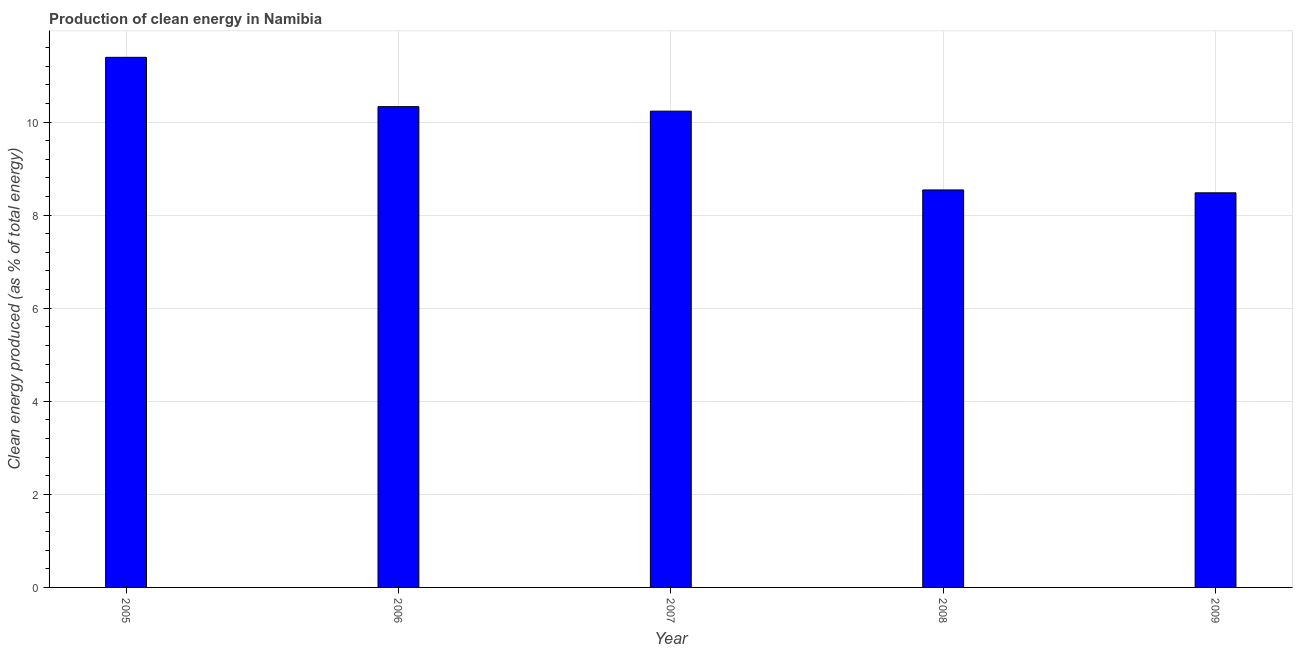Does the graph contain any zero values?
Give a very brief answer. No. Does the graph contain grids?
Offer a terse response. Yes. What is the title of the graph?
Ensure brevity in your answer.  Production of clean energy in Namibia. What is the label or title of the X-axis?
Provide a short and direct response. Year. What is the label or title of the Y-axis?
Make the answer very short. Clean energy produced (as % of total energy). What is the production of clean energy in 2007?
Your answer should be very brief. 10.23. Across all years, what is the maximum production of clean energy?
Make the answer very short. 11.39. Across all years, what is the minimum production of clean energy?
Your answer should be very brief. 8.48. In which year was the production of clean energy maximum?
Keep it short and to the point. 2005. In which year was the production of clean energy minimum?
Keep it short and to the point. 2009. What is the sum of the production of clean energy?
Provide a succinct answer. 48.98. What is the difference between the production of clean energy in 2007 and 2008?
Your answer should be very brief. 1.69. What is the average production of clean energy per year?
Offer a very short reply. 9.79. What is the median production of clean energy?
Make the answer very short. 10.23. What is the ratio of the production of clean energy in 2008 to that in 2009?
Your response must be concise. 1.01. Is the production of clean energy in 2006 less than that in 2008?
Provide a succinct answer. No. What is the difference between the highest and the second highest production of clean energy?
Make the answer very short. 1.06. Is the sum of the production of clean energy in 2005 and 2008 greater than the maximum production of clean energy across all years?
Your answer should be compact. Yes. What is the difference between the highest and the lowest production of clean energy?
Make the answer very short. 2.91. In how many years, is the production of clean energy greater than the average production of clean energy taken over all years?
Give a very brief answer. 3. Are all the bars in the graph horizontal?
Make the answer very short. No. How many years are there in the graph?
Your answer should be very brief. 5. Are the values on the major ticks of Y-axis written in scientific E-notation?
Make the answer very short. No. What is the Clean energy produced (as % of total energy) in 2005?
Offer a very short reply. 11.39. What is the Clean energy produced (as % of total energy) of 2006?
Make the answer very short. 10.33. What is the Clean energy produced (as % of total energy) of 2007?
Provide a succinct answer. 10.23. What is the Clean energy produced (as % of total energy) in 2008?
Keep it short and to the point. 8.54. What is the Clean energy produced (as % of total energy) in 2009?
Give a very brief answer. 8.48. What is the difference between the Clean energy produced (as % of total energy) in 2005 and 2006?
Offer a terse response. 1.06. What is the difference between the Clean energy produced (as % of total energy) in 2005 and 2007?
Provide a short and direct response. 1.16. What is the difference between the Clean energy produced (as % of total energy) in 2005 and 2008?
Provide a short and direct response. 2.85. What is the difference between the Clean energy produced (as % of total energy) in 2005 and 2009?
Provide a succinct answer. 2.91. What is the difference between the Clean energy produced (as % of total energy) in 2006 and 2007?
Offer a terse response. 0.1. What is the difference between the Clean energy produced (as % of total energy) in 2006 and 2008?
Keep it short and to the point. 1.79. What is the difference between the Clean energy produced (as % of total energy) in 2006 and 2009?
Your answer should be compact. 1.85. What is the difference between the Clean energy produced (as % of total energy) in 2007 and 2008?
Provide a short and direct response. 1.69. What is the difference between the Clean energy produced (as % of total energy) in 2007 and 2009?
Your response must be concise. 1.75. What is the difference between the Clean energy produced (as % of total energy) in 2008 and 2009?
Your answer should be compact. 0.06. What is the ratio of the Clean energy produced (as % of total energy) in 2005 to that in 2006?
Make the answer very short. 1.1. What is the ratio of the Clean energy produced (as % of total energy) in 2005 to that in 2007?
Give a very brief answer. 1.11. What is the ratio of the Clean energy produced (as % of total energy) in 2005 to that in 2008?
Your answer should be compact. 1.33. What is the ratio of the Clean energy produced (as % of total energy) in 2005 to that in 2009?
Your answer should be compact. 1.34. What is the ratio of the Clean energy produced (as % of total energy) in 2006 to that in 2007?
Provide a short and direct response. 1.01. What is the ratio of the Clean energy produced (as % of total energy) in 2006 to that in 2008?
Offer a very short reply. 1.21. What is the ratio of the Clean energy produced (as % of total energy) in 2006 to that in 2009?
Keep it short and to the point. 1.22. What is the ratio of the Clean energy produced (as % of total energy) in 2007 to that in 2008?
Your answer should be very brief. 1.2. What is the ratio of the Clean energy produced (as % of total energy) in 2007 to that in 2009?
Offer a very short reply. 1.21. 